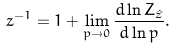Convert formula to latex. <formula><loc_0><loc_0><loc_500><loc_500>z ^ { - 1 } = 1 + \lim _ { p \rightarrow 0 } \frac { d \ln Z _ { \hat { z } } } { d \ln p } .</formula> 